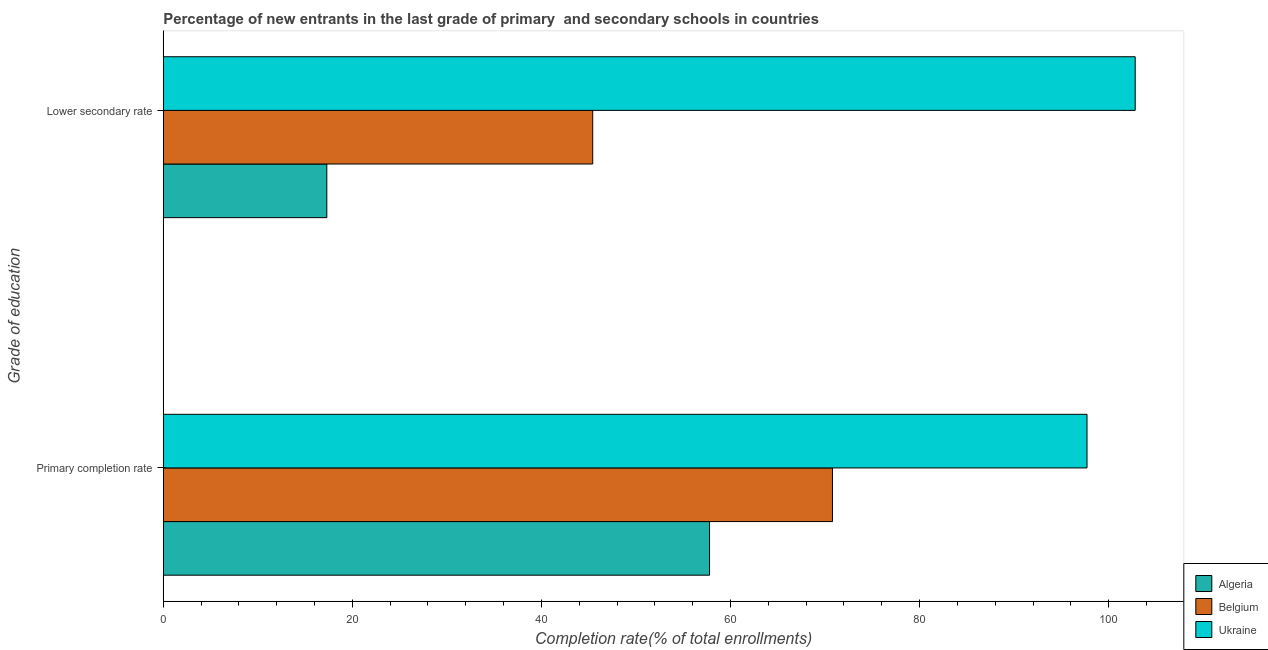How many different coloured bars are there?
Provide a short and direct response. 3. How many groups of bars are there?
Offer a very short reply. 2. What is the label of the 2nd group of bars from the top?
Ensure brevity in your answer.  Primary completion rate. What is the completion rate in primary schools in Ukraine?
Provide a short and direct response. 97.71. Across all countries, what is the maximum completion rate in secondary schools?
Make the answer very short. 102.8. Across all countries, what is the minimum completion rate in secondary schools?
Keep it short and to the point. 17.3. In which country was the completion rate in secondary schools maximum?
Provide a succinct answer. Ukraine. In which country was the completion rate in secondary schools minimum?
Make the answer very short. Algeria. What is the total completion rate in primary schools in the graph?
Offer a very short reply. 226.27. What is the difference between the completion rate in primary schools in Ukraine and that in Belgium?
Ensure brevity in your answer.  26.92. What is the difference between the completion rate in primary schools in Ukraine and the completion rate in secondary schools in Belgium?
Provide a short and direct response. 52.28. What is the average completion rate in secondary schools per country?
Make the answer very short. 55.18. What is the difference between the completion rate in primary schools and completion rate in secondary schools in Ukraine?
Keep it short and to the point. -5.1. In how many countries, is the completion rate in primary schools greater than 100 %?
Ensure brevity in your answer.  0. What is the ratio of the completion rate in secondary schools in Algeria to that in Belgium?
Your response must be concise. 0.38. In how many countries, is the completion rate in secondary schools greater than the average completion rate in secondary schools taken over all countries?
Keep it short and to the point. 1. What does the 3rd bar from the bottom in Lower secondary rate represents?
Provide a short and direct response. Ukraine. Are all the bars in the graph horizontal?
Offer a terse response. Yes. How many countries are there in the graph?
Give a very brief answer. 3. What is the difference between two consecutive major ticks on the X-axis?
Provide a short and direct response. 20. How are the legend labels stacked?
Your response must be concise. Vertical. What is the title of the graph?
Offer a very short reply. Percentage of new entrants in the last grade of primary  and secondary schools in countries. Does "Madagascar" appear as one of the legend labels in the graph?
Your answer should be very brief. No. What is the label or title of the X-axis?
Offer a terse response. Completion rate(% of total enrollments). What is the label or title of the Y-axis?
Ensure brevity in your answer.  Grade of education. What is the Completion rate(% of total enrollments) in Algeria in Primary completion rate?
Keep it short and to the point. 57.78. What is the Completion rate(% of total enrollments) of Belgium in Primary completion rate?
Provide a succinct answer. 70.78. What is the Completion rate(% of total enrollments) of Ukraine in Primary completion rate?
Provide a succinct answer. 97.71. What is the Completion rate(% of total enrollments) of Algeria in Lower secondary rate?
Offer a very short reply. 17.3. What is the Completion rate(% of total enrollments) of Belgium in Lower secondary rate?
Your answer should be very brief. 45.42. What is the Completion rate(% of total enrollments) in Ukraine in Lower secondary rate?
Your answer should be very brief. 102.8. Across all Grade of education, what is the maximum Completion rate(% of total enrollments) in Algeria?
Your response must be concise. 57.78. Across all Grade of education, what is the maximum Completion rate(% of total enrollments) in Belgium?
Offer a terse response. 70.78. Across all Grade of education, what is the maximum Completion rate(% of total enrollments) in Ukraine?
Your answer should be compact. 102.8. Across all Grade of education, what is the minimum Completion rate(% of total enrollments) of Algeria?
Give a very brief answer. 17.3. Across all Grade of education, what is the minimum Completion rate(% of total enrollments) in Belgium?
Your response must be concise. 45.42. Across all Grade of education, what is the minimum Completion rate(% of total enrollments) in Ukraine?
Your answer should be compact. 97.71. What is the total Completion rate(% of total enrollments) of Algeria in the graph?
Your response must be concise. 75.08. What is the total Completion rate(% of total enrollments) of Belgium in the graph?
Ensure brevity in your answer.  116.21. What is the total Completion rate(% of total enrollments) in Ukraine in the graph?
Provide a succinct answer. 200.51. What is the difference between the Completion rate(% of total enrollments) of Algeria in Primary completion rate and that in Lower secondary rate?
Offer a very short reply. 40.49. What is the difference between the Completion rate(% of total enrollments) of Belgium in Primary completion rate and that in Lower secondary rate?
Your response must be concise. 25.36. What is the difference between the Completion rate(% of total enrollments) of Ukraine in Primary completion rate and that in Lower secondary rate?
Provide a succinct answer. -5.1. What is the difference between the Completion rate(% of total enrollments) of Algeria in Primary completion rate and the Completion rate(% of total enrollments) of Belgium in Lower secondary rate?
Offer a terse response. 12.36. What is the difference between the Completion rate(% of total enrollments) in Algeria in Primary completion rate and the Completion rate(% of total enrollments) in Ukraine in Lower secondary rate?
Give a very brief answer. -45.02. What is the difference between the Completion rate(% of total enrollments) in Belgium in Primary completion rate and the Completion rate(% of total enrollments) in Ukraine in Lower secondary rate?
Keep it short and to the point. -32.02. What is the average Completion rate(% of total enrollments) of Algeria per Grade of education?
Your response must be concise. 37.54. What is the average Completion rate(% of total enrollments) of Belgium per Grade of education?
Your answer should be compact. 58.1. What is the average Completion rate(% of total enrollments) of Ukraine per Grade of education?
Offer a terse response. 100.26. What is the difference between the Completion rate(% of total enrollments) in Algeria and Completion rate(% of total enrollments) in Belgium in Primary completion rate?
Your answer should be compact. -13. What is the difference between the Completion rate(% of total enrollments) in Algeria and Completion rate(% of total enrollments) in Ukraine in Primary completion rate?
Your answer should be very brief. -39.92. What is the difference between the Completion rate(% of total enrollments) in Belgium and Completion rate(% of total enrollments) in Ukraine in Primary completion rate?
Provide a succinct answer. -26.92. What is the difference between the Completion rate(% of total enrollments) of Algeria and Completion rate(% of total enrollments) of Belgium in Lower secondary rate?
Offer a terse response. -28.13. What is the difference between the Completion rate(% of total enrollments) in Algeria and Completion rate(% of total enrollments) in Ukraine in Lower secondary rate?
Your response must be concise. -85.51. What is the difference between the Completion rate(% of total enrollments) in Belgium and Completion rate(% of total enrollments) in Ukraine in Lower secondary rate?
Your answer should be compact. -57.38. What is the ratio of the Completion rate(% of total enrollments) in Algeria in Primary completion rate to that in Lower secondary rate?
Make the answer very short. 3.34. What is the ratio of the Completion rate(% of total enrollments) in Belgium in Primary completion rate to that in Lower secondary rate?
Your answer should be very brief. 1.56. What is the ratio of the Completion rate(% of total enrollments) of Ukraine in Primary completion rate to that in Lower secondary rate?
Offer a terse response. 0.95. What is the difference between the highest and the second highest Completion rate(% of total enrollments) of Algeria?
Your response must be concise. 40.49. What is the difference between the highest and the second highest Completion rate(% of total enrollments) in Belgium?
Provide a short and direct response. 25.36. What is the difference between the highest and the second highest Completion rate(% of total enrollments) in Ukraine?
Offer a terse response. 5.1. What is the difference between the highest and the lowest Completion rate(% of total enrollments) of Algeria?
Provide a succinct answer. 40.49. What is the difference between the highest and the lowest Completion rate(% of total enrollments) of Belgium?
Your response must be concise. 25.36. What is the difference between the highest and the lowest Completion rate(% of total enrollments) in Ukraine?
Give a very brief answer. 5.1. 